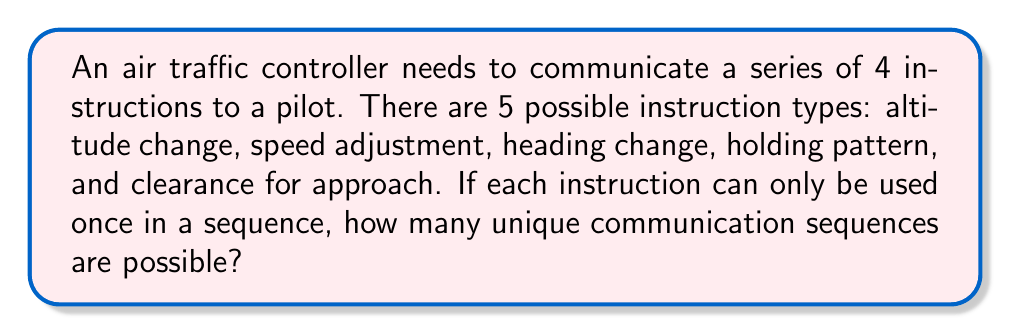Solve this math problem. To solve this problem, we need to use the concept of permutations. Here's a step-by-step explanation:

1. We are selecting 4 instructions out of 5 possible types, where order matters (since we're creating a sequence) and repetition is not allowed.

2. This scenario is a perfect fit for the permutation formula:
   $$P(n,r) = \frac{n!}{(n-r)!}$$
   where $n$ is the total number of items to choose from, and $r$ is the number of items being chosen.

3. In this case:
   $n = 5$ (total number of instruction types)
   $r = 4$ (number of instructions in each sequence)

4. Plugging these values into the formula:
   $$P(5,4) = \frac{5!}{(5-4)!} = \frac{5!}{1!}$$

5. Expand this:
   $$\frac{5 \times 4 \times 3 \times 2 \times 1}{1} = 120$$

Therefore, there are 120 unique communication sequences possible.

This large number of possibilities highlights the complexity of air traffic control communications and the importance of clear, standardized procedures in high-pressure situations.
Answer: 120 unique communication sequences 